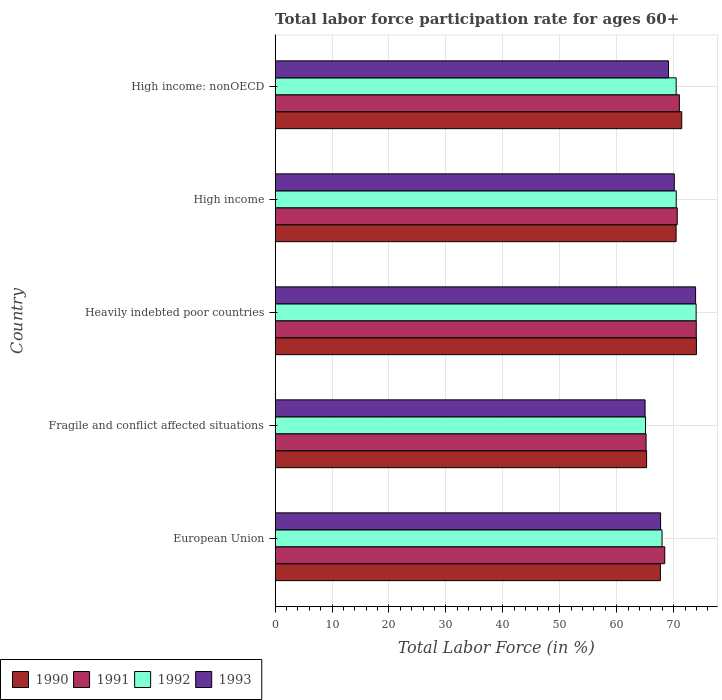How many groups of bars are there?
Your answer should be compact. 5. Are the number of bars on each tick of the Y-axis equal?
Your response must be concise. Yes. How many bars are there on the 1st tick from the top?
Offer a terse response. 4. What is the labor force participation rate in 1992 in European Union?
Give a very brief answer. 67.95. Across all countries, what is the maximum labor force participation rate in 1992?
Your answer should be compact. 73.93. Across all countries, what is the minimum labor force participation rate in 1990?
Offer a very short reply. 65.24. In which country was the labor force participation rate in 1993 maximum?
Give a very brief answer. Heavily indebted poor countries. In which country was the labor force participation rate in 1991 minimum?
Your answer should be compact. Fragile and conflict affected situations. What is the total labor force participation rate in 1991 in the graph?
Your answer should be very brief. 349.13. What is the difference between the labor force participation rate in 1991 in European Union and that in High income?
Give a very brief answer. -2.19. What is the difference between the labor force participation rate in 1990 in Fragile and conflict affected situations and the labor force participation rate in 1992 in European Union?
Offer a terse response. -2.71. What is the average labor force participation rate in 1991 per country?
Your response must be concise. 69.83. What is the difference between the labor force participation rate in 1992 and labor force participation rate in 1990 in Fragile and conflict affected situations?
Ensure brevity in your answer.  -0.18. In how many countries, is the labor force participation rate in 1992 greater than 38 %?
Give a very brief answer. 5. What is the ratio of the labor force participation rate in 1992 in Fragile and conflict affected situations to that in High income: nonOECD?
Provide a short and direct response. 0.92. What is the difference between the highest and the second highest labor force participation rate in 1993?
Your answer should be compact. 3.74. What is the difference between the highest and the lowest labor force participation rate in 1990?
Keep it short and to the point. 8.75. In how many countries, is the labor force participation rate in 1993 greater than the average labor force participation rate in 1993 taken over all countries?
Ensure brevity in your answer.  2. Is the sum of the labor force participation rate in 1990 in Fragile and conflict affected situations and High income greater than the maximum labor force participation rate in 1991 across all countries?
Keep it short and to the point. Yes. What does the 2nd bar from the bottom in Fragile and conflict affected situations represents?
Your response must be concise. 1991. Is it the case that in every country, the sum of the labor force participation rate in 1993 and labor force participation rate in 1992 is greater than the labor force participation rate in 1990?
Your answer should be very brief. Yes. How many bars are there?
Keep it short and to the point. 20. What is the difference between two consecutive major ticks on the X-axis?
Keep it short and to the point. 10. Does the graph contain grids?
Ensure brevity in your answer.  Yes. What is the title of the graph?
Your answer should be compact. Total labor force participation rate for ages 60+. What is the Total Labor Force (in %) of 1990 in European Union?
Your answer should be very brief. 67.66. What is the Total Labor Force (in %) of 1991 in European Union?
Keep it short and to the point. 68.42. What is the Total Labor Force (in %) in 1992 in European Union?
Your answer should be very brief. 67.95. What is the Total Labor Force (in %) of 1993 in European Union?
Make the answer very short. 67.69. What is the Total Labor Force (in %) in 1990 in Fragile and conflict affected situations?
Give a very brief answer. 65.24. What is the Total Labor Force (in %) in 1991 in Fragile and conflict affected situations?
Make the answer very short. 65.15. What is the Total Labor Force (in %) of 1992 in Fragile and conflict affected situations?
Your response must be concise. 65.05. What is the Total Labor Force (in %) of 1993 in Fragile and conflict affected situations?
Provide a succinct answer. 64.97. What is the Total Labor Force (in %) in 1990 in Heavily indebted poor countries?
Your answer should be compact. 73.99. What is the Total Labor Force (in %) of 1991 in Heavily indebted poor countries?
Your answer should be very brief. 73.96. What is the Total Labor Force (in %) of 1992 in Heavily indebted poor countries?
Give a very brief answer. 73.93. What is the Total Labor Force (in %) in 1993 in Heavily indebted poor countries?
Provide a short and direct response. 73.84. What is the Total Labor Force (in %) of 1990 in High income?
Ensure brevity in your answer.  70.42. What is the Total Labor Force (in %) of 1991 in High income?
Your answer should be compact. 70.62. What is the Total Labor Force (in %) of 1992 in High income?
Give a very brief answer. 70.44. What is the Total Labor Force (in %) in 1993 in High income?
Give a very brief answer. 70.1. What is the Total Labor Force (in %) in 1990 in High income: nonOECD?
Keep it short and to the point. 71.41. What is the Total Labor Force (in %) in 1991 in High income: nonOECD?
Make the answer very short. 70.99. What is the Total Labor Force (in %) in 1992 in High income: nonOECD?
Offer a terse response. 70.43. What is the Total Labor Force (in %) in 1993 in High income: nonOECD?
Ensure brevity in your answer.  69.09. Across all countries, what is the maximum Total Labor Force (in %) of 1990?
Provide a succinct answer. 73.99. Across all countries, what is the maximum Total Labor Force (in %) in 1991?
Your answer should be compact. 73.96. Across all countries, what is the maximum Total Labor Force (in %) of 1992?
Provide a short and direct response. 73.93. Across all countries, what is the maximum Total Labor Force (in %) in 1993?
Give a very brief answer. 73.84. Across all countries, what is the minimum Total Labor Force (in %) in 1990?
Offer a terse response. 65.24. Across all countries, what is the minimum Total Labor Force (in %) in 1991?
Make the answer very short. 65.15. Across all countries, what is the minimum Total Labor Force (in %) in 1992?
Provide a succinct answer. 65.05. Across all countries, what is the minimum Total Labor Force (in %) of 1993?
Your answer should be very brief. 64.97. What is the total Total Labor Force (in %) of 1990 in the graph?
Your answer should be very brief. 348.71. What is the total Total Labor Force (in %) of 1991 in the graph?
Make the answer very short. 349.13. What is the total Total Labor Force (in %) in 1992 in the graph?
Keep it short and to the point. 347.81. What is the total Total Labor Force (in %) of 1993 in the graph?
Provide a succinct answer. 345.69. What is the difference between the Total Labor Force (in %) in 1990 in European Union and that in Fragile and conflict affected situations?
Your response must be concise. 2.42. What is the difference between the Total Labor Force (in %) in 1991 in European Union and that in Fragile and conflict affected situations?
Make the answer very short. 3.28. What is the difference between the Total Labor Force (in %) in 1992 in European Union and that in Fragile and conflict affected situations?
Offer a terse response. 2.9. What is the difference between the Total Labor Force (in %) of 1993 in European Union and that in Fragile and conflict affected situations?
Make the answer very short. 2.72. What is the difference between the Total Labor Force (in %) of 1990 in European Union and that in Heavily indebted poor countries?
Your answer should be compact. -6.33. What is the difference between the Total Labor Force (in %) of 1991 in European Union and that in Heavily indebted poor countries?
Your answer should be compact. -5.54. What is the difference between the Total Labor Force (in %) in 1992 in European Union and that in Heavily indebted poor countries?
Your answer should be very brief. -5.98. What is the difference between the Total Labor Force (in %) of 1993 in European Union and that in Heavily indebted poor countries?
Provide a short and direct response. -6.15. What is the difference between the Total Labor Force (in %) of 1990 in European Union and that in High income?
Your response must be concise. -2.76. What is the difference between the Total Labor Force (in %) of 1991 in European Union and that in High income?
Ensure brevity in your answer.  -2.19. What is the difference between the Total Labor Force (in %) in 1992 in European Union and that in High income?
Your answer should be very brief. -2.49. What is the difference between the Total Labor Force (in %) of 1993 in European Union and that in High income?
Provide a succinct answer. -2.41. What is the difference between the Total Labor Force (in %) of 1990 in European Union and that in High income: nonOECD?
Provide a succinct answer. -3.75. What is the difference between the Total Labor Force (in %) in 1991 in European Union and that in High income: nonOECD?
Ensure brevity in your answer.  -2.57. What is the difference between the Total Labor Force (in %) of 1992 in European Union and that in High income: nonOECD?
Offer a very short reply. -2.48. What is the difference between the Total Labor Force (in %) in 1993 in European Union and that in High income: nonOECD?
Your answer should be very brief. -1.39. What is the difference between the Total Labor Force (in %) of 1990 in Fragile and conflict affected situations and that in Heavily indebted poor countries?
Your response must be concise. -8.75. What is the difference between the Total Labor Force (in %) of 1991 in Fragile and conflict affected situations and that in Heavily indebted poor countries?
Offer a very short reply. -8.81. What is the difference between the Total Labor Force (in %) of 1992 in Fragile and conflict affected situations and that in Heavily indebted poor countries?
Make the answer very short. -8.88. What is the difference between the Total Labor Force (in %) in 1993 in Fragile and conflict affected situations and that in Heavily indebted poor countries?
Offer a terse response. -8.87. What is the difference between the Total Labor Force (in %) of 1990 in Fragile and conflict affected situations and that in High income?
Keep it short and to the point. -5.18. What is the difference between the Total Labor Force (in %) in 1991 in Fragile and conflict affected situations and that in High income?
Give a very brief answer. -5.47. What is the difference between the Total Labor Force (in %) in 1992 in Fragile and conflict affected situations and that in High income?
Give a very brief answer. -5.39. What is the difference between the Total Labor Force (in %) in 1993 in Fragile and conflict affected situations and that in High income?
Offer a terse response. -5.13. What is the difference between the Total Labor Force (in %) of 1990 in Fragile and conflict affected situations and that in High income: nonOECD?
Provide a succinct answer. -6.17. What is the difference between the Total Labor Force (in %) of 1991 in Fragile and conflict affected situations and that in High income: nonOECD?
Your response must be concise. -5.84. What is the difference between the Total Labor Force (in %) in 1992 in Fragile and conflict affected situations and that in High income: nonOECD?
Keep it short and to the point. -5.38. What is the difference between the Total Labor Force (in %) of 1993 in Fragile and conflict affected situations and that in High income: nonOECD?
Provide a short and direct response. -4.12. What is the difference between the Total Labor Force (in %) of 1990 in Heavily indebted poor countries and that in High income?
Offer a very short reply. 3.57. What is the difference between the Total Labor Force (in %) in 1991 in Heavily indebted poor countries and that in High income?
Provide a succinct answer. 3.34. What is the difference between the Total Labor Force (in %) in 1992 in Heavily indebted poor countries and that in High income?
Provide a succinct answer. 3.49. What is the difference between the Total Labor Force (in %) in 1993 in Heavily indebted poor countries and that in High income?
Provide a short and direct response. 3.74. What is the difference between the Total Labor Force (in %) in 1990 in Heavily indebted poor countries and that in High income: nonOECD?
Ensure brevity in your answer.  2.58. What is the difference between the Total Labor Force (in %) of 1991 in Heavily indebted poor countries and that in High income: nonOECD?
Your answer should be compact. 2.97. What is the difference between the Total Labor Force (in %) in 1992 in Heavily indebted poor countries and that in High income: nonOECD?
Your answer should be very brief. 3.5. What is the difference between the Total Labor Force (in %) in 1993 in Heavily indebted poor countries and that in High income: nonOECD?
Your answer should be compact. 4.76. What is the difference between the Total Labor Force (in %) in 1990 in High income and that in High income: nonOECD?
Your answer should be very brief. -0.99. What is the difference between the Total Labor Force (in %) in 1991 in High income and that in High income: nonOECD?
Ensure brevity in your answer.  -0.37. What is the difference between the Total Labor Force (in %) of 1992 in High income and that in High income: nonOECD?
Offer a terse response. 0.01. What is the difference between the Total Labor Force (in %) of 1993 in High income and that in High income: nonOECD?
Give a very brief answer. 1.02. What is the difference between the Total Labor Force (in %) of 1990 in European Union and the Total Labor Force (in %) of 1991 in Fragile and conflict affected situations?
Your answer should be compact. 2.51. What is the difference between the Total Labor Force (in %) in 1990 in European Union and the Total Labor Force (in %) in 1992 in Fragile and conflict affected situations?
Offer a terse response. 2.61. What is the difference between the Total Labor Force (in %) of 1990 in European Union and the Total Labor Force (in %) of 1993 in Fragile and conflict affected situations?
Make the answer very short. 2.69. What is the difference between the Total Labor Force (in %) of 1991 in European Union and the Total Labor Force (in %) of 1992 in Fragile and conflict affected situations?
Ensure brevity in your answer.  3.37. What is the difference between the Total Labor Force (in %) of 1991 in European Union and the Total Labor Force (in %) of 1993 in Fragile and conflict affected situations?
Provide a succinct answer. 3.45. What is the difference between the Total Labor Force (in %) in 1992 in European Union and the Total Labor Force (in %) in 1993 in Fragile and conflict affected situations?
Make the answer very short. 2.98. What is the difference between the Total Labor Force (in %) in 1990 in European Union and the Total Labor Force (in %) in 1991 in Heavily indebted poor countries?
Provide a short and direct response. -6.3. What is the difference between the Total Labor Force (in %) in 1990 in European Union and the Total Labor Force (in %) in 1992 in Heavily indebted poor countries?
Make the answer very short. -6.27. What is the difference between the Total Labor Force (in %) of 1990 in European Union and the Total Labor Force (in %) of 1993 in Heavily indebted poor countries?
Keep it short and to the point. -6.18. What is the difference between the Total Labor Force (in %) in 1991 in European Union and the Total Labor Force (in %) in 1992 in Heavily indebted poor countries?
Your answer should be compact. -5.51. What is the difference between the Total Labor Force (in %) in 1991 in European Union and the Total Labor Force (in %) in 1993 in Heavily indebted poor countries?
Your response must be concise. -5.42. What is the difference between the Total Labor Force (in %) of 1992 in European Union and the Total Labor Force (in %) of 1993 in Heavily indebted poor countries?
Provide a succinct answer. -5.89. What is the difference between the Total Labor Force (in %) in 1990 in European Union and the Total Labor Force (in %) in 1991 in High income?
Ensure brevity in your answer.  -2.96. What is the difference between the Total Labor Force (in %) of 1990 in European Union and the Total Labor Force (in %) of 1992 in High income?
Offer a terse response. -2.78. What is the difference between the Total Labor Force (in %) of 1990 in European Union and the Total Labor Force (in %) of 1993 in High income?
Provide a short and direct response. -2.44. What is the difference between the Total Labor Force (in %) of 1991 in European Union and the Total Labor Force (in %) of 1992 in High income?
Your response must be concise. -2.02. What is the difference between the Total Labor Force (in %) in 1991 in European Union and the Total Labor Force (in %) in 1993 in High income?
Ensure brevity in your answer.  -1.68. What is the difference between the Total Labor Force (in %) in 1992 in European Union and the Total Labor Force (in %) in 1993 in High income?
Offer a terse response. -2.15. What is the difference between the Total Labor Force (in %) in 1990 in European Union and the Total Labor Force (in %) in 1991 in High income: nonOECD?
Your response must be concise. -3.33. What is the difference between the Total Labor Force (in %) in 1990 in European Union and the Total Labor Force (in %) in 1992 in High income: nonOECD?
Make the answer very short. -2.77. What is the difference between the Total Labor Force (in %) of 1990 in European Union and the Total Labor Force (in %) of 1993 in High income: nonOECD?
Ensure brevity in your answer.  -1.43. What is the difference between the Total Labor Force (in %) in 1991 in European Union and the Total Labor Force (in %) in 1992 in High income: nonOECD?
Your response must be concise. -2.01. What is the difference between the Total Labor Force (in %) of 1991 in European Union and the Total Labor Force (in %) of 1993 in High income: nonOECD?
Give a very brief answer. -0.66. What is the difference between the Total Labor Force (in %) in 1992 in European Union and the Total Labor Force (in %) in 1993 in High income: nonOECD?
Provide a short and direct response. -1.14. What is the difference between the Total Labor Force (in %) of 1990 in Fragile and conflict affected situations and the Total Labor Force (in %) of 1991 in Heavily indebted poor countries?
Provide a short and direct response. -8.72. What is the difference between the Total Labor Force (in %) of 1990 in Fragile and conflict affected situations and the Total Labor Force (in %) of 1992 in Heavily indebted poor countries?
Provide a succinct answer. -8.7. What is the difference between the Total Labor Force (in %) in 1990 in Fragile and conflict affected situations and the Total Labor Force (in %) in 1993 in Heavily indebted poor countries?
Your answer should be very brief. -8.61. What is the difference between the Total Labor Force (in %) in 1991 in Fragile and conflict affected situations and the Total Labor Force (in %) in 1992 in Heavily indebted poor countries?
Provide a short and direct response. -8.79. What is the difference between the Total Labor Force (in %) in 1991 in Fragile and conflict affected situations and the Total Labor Force (in %) in 1993 in Heavily indebted poor countries?
Your answer should be compact. -8.7. What is the difference between the Total Labor Force (in %) in 1992 in Fragile and conflict affected situations and the Total Labor Force (in %) in 1993 in Heavily indebted poor countries?
Your answer should be compact. -8.79. What is the difference between the Total Labor Force (in %) of 1990 in Fragile and conflict affected situations and the Total Labor Force (in %) of 1991 in High income?
Offer a very short reply. -5.38. What is the difference between the Total Labor Force (in %) of 1990 in Fragile and conflict affected situations and the Total Labor Force (in %) of 1992 in High income?
Provide a short and direct response. -5.21. What is the difference between the Total Labor Force (in %) in 1990 in Fragile and conflict affected situations and the Total Labor Force (in %) in 1993 in High income?
Your response must be concise. -4.87. What is the difference between the Total Labor Force (in %) in 1991 in Fragile and conflict affected situations and the Total Labor Force (in %) in 1992 in High income?
Make the answer very short. -5.3. What is the difference between the Total Labor Force (in %) in 1991 in Fragile and conflict affected situations and the Total Labor Force (in %) in 1993 in High income?
Provide a short and direct response. -4.96. What is the difference between the Total Labor Force (in %) in 1992 in Fragile and conflict affected situations and the Total Labor Force (in %) in 1993 in High income?
Your response must be concise. -5.05. What is the difference between the Total Labor Force (in %) of 1990 in Fragile and conflict affected situations and the Total Labor Force (in %) of 1991 in High income: nonOECD?
Provide a succinct answer. -5.75. What is the difference between the Total Labor Force (in %) in 1990 in Fragile and conflict affected situations and the Total Labor Force (in %) in 1992 in High income: nonOECD?
Ensure brevity in your answer.  -5.2. What is the difference between the Total Labor Force (in %) in 1990 in Fragile and conflict affected situations and the Total Labor Force (in %) in 1993 in High income: nonOECD?
Ensure brevity in your answer.  -3.85. What is the difference between the Total Labor Force (in %) of 1991 in Fragile and conflict affected situations and the Total Labor Force (in %) of 1992 in High income: nonOECD?
Offer a very short reply. -5.29. What is the difference between the Total Labor Force (in %) of 1991 in Fragile and conflict affected situations and the Total Labor Force (in %) of 1993 in High income: nonOECD?
Your answer should be very brief. -3.94. What is the difference between the Total Labor Force (in %) of 1992 in Fragile and conflict affected situations and the Total Labor Force (in %) of 1993 in High income: nonOECD?
Your answer should be very brief. -4.03. What is the difference between the Total Labor Force (in %) in 1990 in Heavily indebted poor countries and the Total Labor Force (in %) in 1991 in High income?
Give a very brief answer. 3.37. What is the difference between the Total Labor Force (in %) of 1990 in Heavily indebted poor countries and the Total Labor Force (in %) of 1992 in High income?
Give a very brief answer. 3.55. What is the difference between the Total Labor Force (in %) of 1990 in Heavily indebted poor countries and the Total Labor Force (in %) of 1993 in High income?
Your answer should be very brief. 3.88. What is the difference between the Total Labor Force (in %) in 1991 in Heavily indebted poor countries and the Total Labor Force (in %) in 1992 in High income?
Ensure brevity in your answer.  3.52. What is the difference between the Total Labor Force (in %) of 1991 in Heavily indebted poor countries and the Total Labor Force (in %) of 1993 in High income?
Give a very brief answer. 3.86. What is the difference between the Total Labor Force (in %) of 1992 in Heavily indebted poor countries and the Total Labor Force (in %) of 1993 in High income?
Your answer should be very brief. 3.83. What is the difference between the Total Labor Force (in %) in 1990 in Heavily indebted poor countries and the Total Labor Force (in %) in 1991 in High income: nonOECD?
Provide a succinct answer. 3. What is the difference between the Total Labor Force (in %) in 1990 in Heavily indebted poor countries and the Total Labor Force (in %) in 1992 in High income: nonOECD?
Ensure brevity in your answer.  3.56. What is the difference between the Total Labor Force (in %) in 1990 in Heavily indebted poor countries and the Total Labor Force (in %) in 1993 in High income: nonOECD?
Ensure brevity in your answer.  4.9. What is the difference between the Total Labor Force (in %) of 1991 in Heavily indebted poor countries and the Total Labor Force (in %) of 1992 in High income: nonOECD?
Keep it short and to the point. 3.53. What is the difference between the Total Labor Force (in %) in 1991 in Heavily indebted poor countries and the Total Labor Force (in %) in 1993 in High income: nonOECD?
Your answer should be compact. 4.87. What is the difference between the Total Labor Force (in %) in 1992 in Heavily indebted poor countries and the Total Labor Force (in %) in 1993 in High income: nonOECD?
Provide a succinct answer. 4.85. What is the difference between the Total Labor Force (in %) of 1990 in High income and the Total Labor Force (in %) of 1991 in High income: nonOECD?
Your answer should be compact. -0.57. What is the difference between the Total Labor Force (in %) in 1990 in High income and the Total Labor Force (in %) in 1992 in High income: nonOECD?
Give a very brief answer. -0.01. What is the difference between the Total Labor Force (in %) in 1990 in High income and the Total Labor Force (in %) in 1993 in High income: nonOECD?
Provide a short and direct response. 1.33. What is the difference between the Total Labor Force (in %) in 1991 in High income and the Total Labor Force (in %) in 1992 in High income: nonOECD?
Keep it short and to the point. 0.18. What is the difference between the Total Labor Force (in %) of 1991 in High income and the Total Labor Force (in %) of 1993 in High income: nonOECD?
Your answer should be very brief. 1.53. What is the difference between the Total Labor Force (in %) of 1992 in High income and the Total Labor Force (in %) of 1993 in High income: nonOECD?
Offer a terse response. 1.36. What is the average Total Labor Force (in %) of 1990 per country?
Offer a terse response. 69.74. What is the average Total Labor Force (in %) in 1991 per country?
Your response must be concise. 69.83. What is the average Total Labor Force (in %) of 1992 per country?
Give a very brief answer. 69.56. What is the average Total Labor Force (in %) in 1993 per country?
Your answer should be compact. 69.14. What is the difference between the Total Labor Force (in %) in 1990 and Total Labor Force (in %) in 1991 in European Union?
Your answer should be compact. -0.76. What is the difference between the Total Labor Force (in %) of 1990 and Total Labor Force (in %) of 1992 in European Union?
Keep it short and to the point. -0.29. What is the difference between the Total Labor Force (in %) of 1990 and Total Labor Force (in %) of 1993 in European Union?
Give a very brief answer. -0.03. What is the difference between the Total Labor Force (in %) of 1991 and Total Labor Force (in %) of 1992 in European Union?
Your response must be concise. 0.47. What is the difference between the Total Labor Force (in %) in 1991 and Total Labor Force (in %) in 1993 in European Union?
Your answer should be very brief. 0.73. What is the difference between the Total Labor Force (in %) in 1992 and Total Labor Force (in %) in 1993 in European Union?
Your answer should be very brief. 0.26. What is the difference between the Total Labor Force (in %) in 1990 and Total Labor Force (in %) in 1991 in Fragile and conflict affected situations?
Keep it short and to the point. 0.09. What is the difference between the Total Labor Force (in %) of 1990 and Total Labor Force (in %) of 1992 in Fragile and conflict affected situations?
Offer a terse response. 0.18. What is the difference between the Total Labor Force (in %) in 1990 and Total Labor Force (in %) in 1993 in Fragile and conflict affected situations?
Ensure brevity in your answer.  0.27. What is the difference between the Total Labor Force (in %) in 1991 and Total Labor Force (in %) in 1992 in Fragile and conflict affected situations?
Keep it short and to the point. 0.09. What is the difference between the Total Labor Force (in %) in 1991 and Total Labor Force (in %) in 1993 in Fragile and conflict affected situations?
Provide a short and direct response. 0.18. What is the difference between the Total Labor Force (in %) in 1992 and Total Labor Force (in %) in 1993 in Fragile and conflict affected situations?
Offer a terse response. 0.08. What is the difference between the Total Labor Force (in %) in 1990 and Total Labor Force (in %) in 1991 in Heavily indebted poor countries?
Your answer should be compact. 0.03. What is the difference between the Total Labor Force (in %) in 1990 and Total Labor Force (in %) in 1992 in Heavily indebted poor countries?
Keep it short and to the point. 0.05. What is the difference between the Total Labor Force (in %) of 1990 and Total Labor Force (in %) of 1993 in Heavily indebted poor countries?
Offer a very short reply. 0.15. What is the difference between the Total Labor Force (in %) of 1991 and Total Labor Force (in %) of 1992 in Heavily indebted poor countries?
Offer a terse response. 0.03. What is the difference between the Total Labor Force (in %) of 1991 and Total Labor Force (in %) of 1993 in Heavily indebted poor countries?
Your response must be concise. 0.12. What is the difference between the Total Labor Force (in %) in 1992 and Total Labor Force (in %) in 1993 in Heavily indebted poor countries?
Offer a terse response. 0.09. What is the difference between the Total Labor Force (in %) of 1990 and Total Labor Force (in %) of 1991 in High income?
Provide a succinct answer. -0.2. What is the difference between the Total Labor Force (in %) of 1990 and Total Labor Force (in %) of 1992 in High income?
Provide a succinct answer. -0.02. What is the difference between the Total Labor Force (in %) in 1990 and Total Labor Force (in %) in 1993 in High income?
Make the answer very short. 0.32. What is the difference between the Total Labor Force (in %) of 1991 and Total Labor Force (in %) of 1992 in High income?
Ensure brevity in your answer.  0.17. What is the difference between the Total Labor Force (in %) in 1991 and Total Labor Force (in %) in 1993 in High income?
Offer a terse response. 0.51. What is the difference between the Total Labor Force (in %) in 1992 and Total Labor Force (in %) in 1993 in High income?
Provide a succinct answer. 0.34. What is the difference between the Total Labor Force (in %) in 1990 and Total Labor Force (in %) in 1991 in High income: nonOECD?
Keep it short and to the point. 0.42. What is the difference between the Total Labor Force (in %) of 1990 and Total Labor Force (in %) of 1992 in High income: nonOECD?
Make the answer very short. 0.98. What is the difference between the Total Labor Force (in %) of 1990 and Total Labor Force (in %) of 1993 in High income: nonOECD?
Offer a terse response. 2.32. What is the difference between the Total Labor Force (in %) in 1991 and Total Labor Force (in %) in 1992 in High income: nonOECD?
Provide a succinct answer. 0.56. What is the difference between the Total Labor Force (in %) in 1991 and Total Labor Force (in %) in 1993 in High income: nonOECD?
Your answer should be very brief. 1.9. What is the difference between the Total Labor Force (in %) of 1992 and Total Labor Force (in %) of 1993 in High income: nonOECD?
Your answer should be compact. 1.35. What is the ratio of the Total Labor Force (in %) in 1990 in European Union to that in Fragile and conflict affected situations?
Give a very brief answer. 1.04. What is the ratio of the Total Labor Force (in %) of 1991 in European Union to that in Fragile and conflict affected situations?
Give a very brief answer. 1.05. What is the ratio of the Total Labor Force (in %) in 1992 in European Union to that in Fragile and conflict affected situations?
Give a very brief answer. 1.04. What is the ratio of the Total Labor Force (in %) in 1993 in European Union to that in Fragile and conflict affected situations?
Your answer should be very brief. 1.04. What is the ratio of the Total Labor Force (in %) of 1990 in European Union to that in Heavily indebted poor countries?
Offer a terse response. 0.91. What is the ratio of the Total Labor Force (in %) in 1991 in European Union to that in Heavily indebted poor countries?
Keep it short and to the point. 0.93. What is the ratio of the Total Labor Force (in %) in 1992 in European Union to that in Heavily indebted poor countries?
Give a very brief answer. 0.92. What is the ratio of the Total Labor Force (in %) of 1993 in European Union to that in Heavily indebted poor countries?
Offer a very short reply. 0.92. What is the ratio of the Total Labor Force (in %) in 1990 in European Union to that in High income?
Your answer should be very brief. 0.96. What is the ratio of the Total Labor Force (in %) in 1991 in European Union to that in High income?
Provide a succinct answer. 0.97. What is the ratio of the Total Labor Force (in %) of 1992 in European Union to that in High income?
Provide a short and direct response. 0.96. What is the ratio of the Total Labor Force (in %) in 1993 in European Union to that in High income?
Your answer should be very brief. 0.97. What is the ratio of the Total Labor Force (in %) in 1990 in European Union to that in High income: nonOECD?
Provide a succinct answer. 0.95. What is the ratio of the Total Labor Force (in %) in 1991 in European Union to that in High income: nonOECD?
Offer a very short reply. 0.96. What is the ratio of the Total Labor Force (in %) in 1992 in European Union to that in High income: nonOECD?
Your answer should be very brief. 0.96. What is the ratio of the Total Labor Force (in %) of 1993 in European Union to that in High income: nonOECD?
Your answer should be compact. 0.98. What is the ratio of the Total Labor Force (in %) in 1990 in Fragile and conflict affected situations to that in Heavily indebted poor countries?
Provide a succinct answer. 0.88. What is the ratio of the Total Labor Force (in %) in 1991 in Fragile and conflict affected situations to that in Heavily indebted poor countries?
Offer a very short reply. 0.88. What is the ratio of the Total Labor Force (in %) of 1992 in Fragile and conflict affected situations to that in Heavily indebted poor countries?
Provide a short and direct response. 0.88. What is the ratio of the Total Labor Force (in %) in 1993 in Fragile and conflict affected situations to that in Heavily indebted poor countries?
Your answer should be very brief. 0.88. What is the ratio of the Total Labor Force (in %) of 1990 in Fragile and conflict affected situations to that in High income?
Keep it short and to the point. 0.93. What is the ratio of the Total Labor Force (in %) of 1991 in Fragile and conflict affected situations to that in High income?
Offer a very short reply. 0.92. What is the ratio of the Total Labor Force (in %) in 1992 in Fragile and conflict affected situations to that in High income?
Provide a succinct answer. 0.92. What is the ratio of the Total Labor Force (in %) in 1993 in Fragile and conflict affected situations to that in High income?
Provide a succinct answer. 0.93. What is the ratio of the Total Labor Force (in %) of 1990 in Fragile and conflict affected situations to that in High income: nonOECD?
Keep it short and to the point. 0.91. What is the ratio of the Total Labor Force (in %) of 1991 in Fragile and conflict affected situations to that in High income: nonOECD?
Provide a succinct answer. 0.92. What is the ratio of the Total Labor Force (in %) in 1992 in Fragile and conflict affected situations to that in High income: nonOECD?
Your response must be concise. 0.92. What is the ratio of the Total Labor Force (in %) in 1993 in Fragile and conflict affected situations to that in High income: nonOECD?
Offer a very short reply. 0.94. What is the ratio of the Total Labor Force (in %) in 1990 in Heavily indebted poor countries to that in High income?
Offer a very short reply. 1.05. What is the ratio of the Total Labor Force (in %) of 1991 in Heavily indebted poor countries to that in High income?
Your response must be concise. 1.05. What is the ratio of the Total Labor Force (in %) of 1992 in Heavily indebted poor countries to that in High income?
Ensure brevity in your answer.  1.05. What is the ratio of the Total Labor Force (in %) of 1993 in Heavily indebted poor countries to that in High income?
Your answer should be compact. 1.05. What is the ratio of the Total Labor Force (in %) in 1990 in Heavily indebted poor countries to that in High income: nonOECD?
Your answer should be very brief. 1.04. What is the ratio of the Total Labor Force (in %) in 1991 in Heavily indebted poor countries to that in High income: nonOECD?
Give a very brief answer. 1.04. What is the ratio of the Total Labor Force (in %) of 1992 in Heavily indebted poor countries to that in High income: nonOECD?
Provide a short and direct response. 1.05. What is the ratio of the Total Labor Force (in %) of 1993 in Heavily indebted poor countries to that in High income: nonOECD?
Your answer should be compact. 1.07. What is the ratio of the Total Labor Force (in %) in 1990 in High income to that in High income: nonOECD?
Provide a succinct answer. 0.99. What is the ratio of the Total Labor Force (in %) of 1991 in High income to that in High income: nonOECD?
Provide a succinct answer. 0.99. What is the ratio of the Total Labor Force (in %) of 1993 in High income to that in High income: nonOECD?
Make the answer very short. 1.01. What is the difference between the highest and the second highest Total Labor Force (in %) of 1990?
Your answer should be compact. 2.58. What is the difference between the highest and the second highest Total Labor Force (in %) of 1991?
Offer a terse response. 2.97. What is the difference between the highest and the second highest Total Labor Force (in %) in 1992?
Keep it short and to the point. 3.49. What is the difference between the highest and the second highest Total Labor Force (in %) in 1993?
Keep it short and to the point. 3.74. What is the difference between the highest and the lowest Total Labor Force (in %) in 1990?
Your answer should be compact. 8.75. What is the difference between the highest and the lowest Total Labor Force (in %) of 1991?
Provide a short and direct response. 8.81. What is the difference between the highest and the lowest Total Labor Force (in %) in 1992?
Your response must be concise. 8.88. What is the difference between the highest and the lowest Total Labor Force (in %) in 1993?
Give a very brief answer. 8.87. 